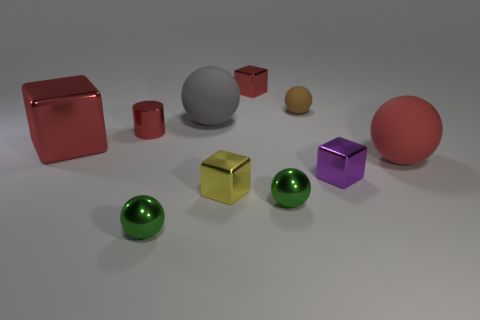There is a tiny brown rubber thing; is it the same shape as the tiny green object that is left of the large gray thing?
Your response must be concise. Yes. How many objects are tiny things that are in front of the purple block or small shiny blocks on the right side of the brown rubber sphere?
Provide a succinct answer. 4. What shape is the big metallic thing that is the same color as the shiny cylinder?
Ensure brevity in your answer.  Cube. The tiny red object to the left of the gray rubber sphere has what shape?
Provide a short and direct response. Cylinder. Does the brown rubber object that is behind the purple block have the same shape as the gray matte object?
Ensure brevity in your answer.  Yes. What number of objects are tiny rubber spheres that are to the right of the yellow cube or tiny yellow metallic cylinders?
Make the answer very short. 1. What color is the other tiny rubber object that is the same shape as the red matte thing?
Your response must be concise. Brown. Are there any other things that are the same color as the tiny rubber thing?
Your answer should be compact. No. There is a red thing that is behind the small red shiny cylinder; what is its size?
Keep it short and to the point. Small. There is a metallic cylinder; is it the same color as the large matte object right of the big gray matte object?
Your response must be concise. Yes. 